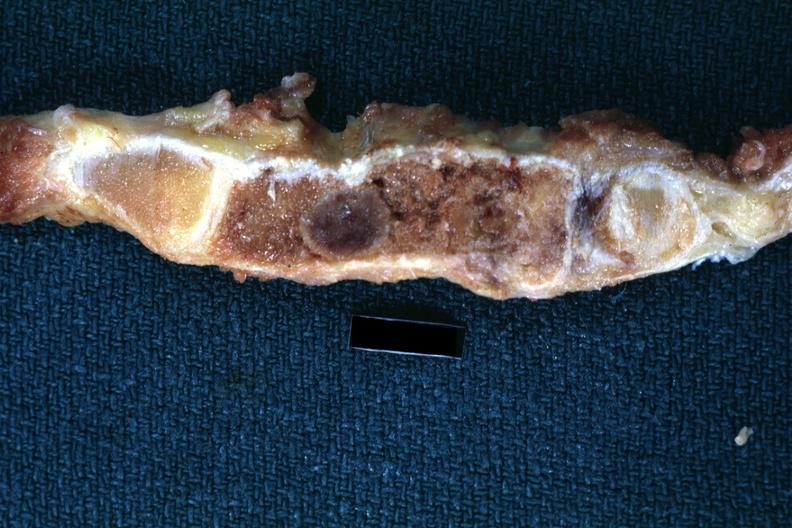s joints present?
Answer the question using a single word or phrase. Yes 